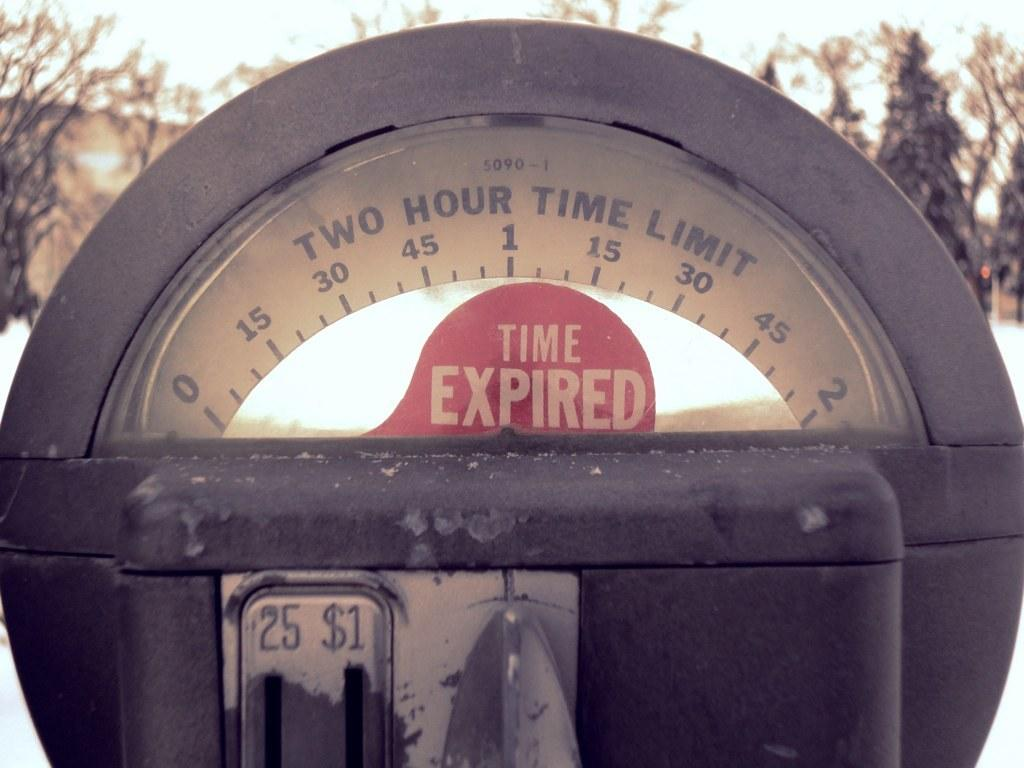<image>
Describe the image concisely. a close up of a parking meter reading Time Expired 